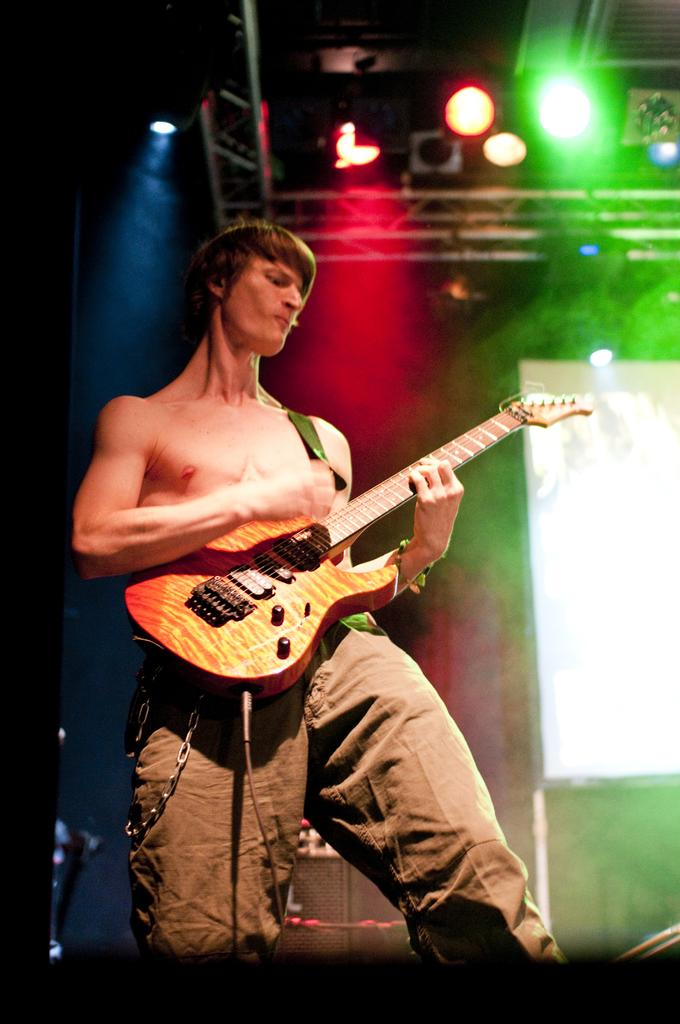What is the main subject of the image? There is a man in the image. What is the man doing in the image? The man is standing in the image. What object is the man holding in the image? The man is holding a guitar in his hand. Can you tell me how many ears of corn are visible in the image? There are no ears of corn present in the image. What type of food is the man cooking in the image? There is no indication that the man is cooking in the image; he is holding a guitar. 